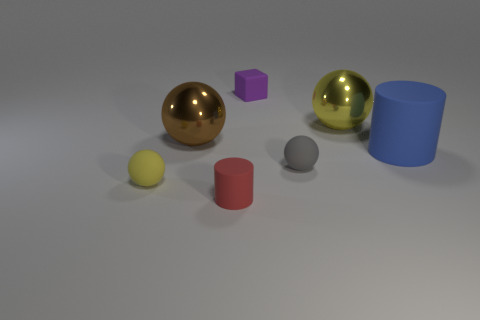There is a purple thing that is the same size as the red rubber object; what shape is it?
Your answer should be very brief. Cube. What number of things are small objects in front of the small cube or tiny blue matte spheres?
Your answer should be compact. 3. Is the number of big yellow metallic balls that are left of the red thing greater than the number of blue matte objects behind the large cylinder?
Keep it short and to the point. No. Does the gray object have the same material as the tiny purple object?
Your response must be concise. Yes. There is a matte thing that is both behind the small gray sphere and left of the big blue rubber thing; what is its shape?
Ensure brevity in your answer.  Cube. What is the shape of the big blue thing that is made of the same material as the tiny purple block?
Make the answer very short. Cylinder. Is there a tiny rubber cylinder?
Make the answer very short. Yes. Are there any balls that are on the left side of the small object that is to the right of the tiny purple rubber block?
Ensure brevity in your answer.  Yes. What material is the big yellow object that is the same shape as the gray object?
Keep it short and to the point. Metal. Are there more small brown metal balls than small rubber things?
Ensure brevity in your answer.  No. 